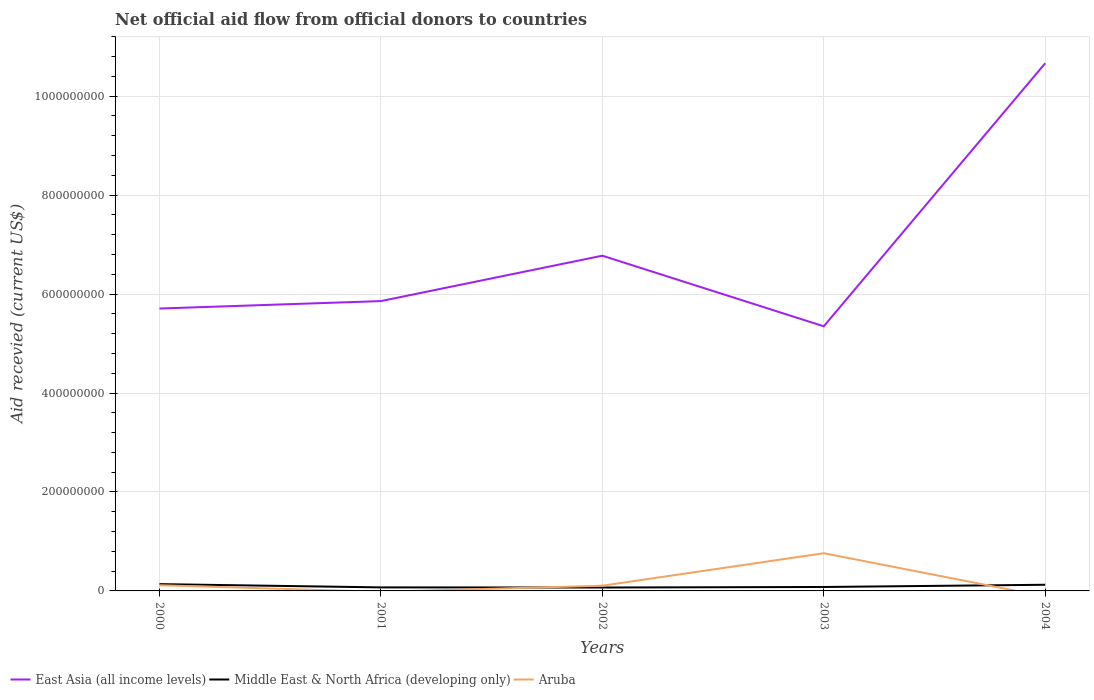How many different coloured lines are there?
Ensure brevity in your answer.  3. Does the line corresponding to East Asia (all income levels) intersect with the line corresponding to Aruba?
Make the answer very short. No. Is the number of lines equal to the number of legend labels?
Provide a succinct answer. No. Across all years, what is the maximum total aid received in Middle East & North Africa (developing only)?
Ensure brevity in your answer.  6.88e+06. What is the total total aid received in East Asia (all income levels) in the graph?
Offer a very short reply. 3.59e+07. What is the difference between the highest and the second highest total aid received in East Asia (all income levels)?
Your answer should be very brief. 5.32e+08. Does the graph contain grids?
Ensure brevity in your answer.  Yes. How many legend labels are there?
Offer a very short reply. 3. What is the title of the graph?
Your answer should be very brief. Net official aid flow from official donors to countries. Does "Burkina Faso" appear as one of the legend labels in the graph?
Your answer should be very brief. No. What is the label or title of the Y-axis?
Give a very brief answer. Aid recevied (current US$). What is the Aid recevied (current US$) of East Asia (all income levels) in 2000?
Your answer should be compact. 5.71e+08. What is the Aid recevied (current US$) of Middle East & North Africa (developing only) in 2000?
Provide a succinct answer. 1.38e+07. What is the Aid recevied (current US$) of Aruba in 2000?
Your response must be concise. 1.15e+07. What is the Aid recevied (current US$) in East Asia (all income levels) in 2001?
Make the answer very short. 5.86e+08. What is the Aid recevied (current US$) of Middle East & North Africa (developing only) in 2001?
Your response must be concise. 7.14e+06. What is the Aid recevied (current US$) of East Asia (all income levels) in 2002?
Ensure brevity in your answer.  6.78e+08. What is the Aid recevied (current US$) of Middle East & North Africa (developing only) in 2002?
Offer a very short reply. 6.88e+06. What is the Aid recevied (current US$) in Aruba in 2002?
Offer a terse response. 1.05e+07. What is the Aid recevied (current US$) of East Asia (all income levels) in 2003?
Give a very brief answer. 5.35e+08. What is the Aid recevied (current US$) in Middle East & North Africa (developing only) in 2003?
Ensure brevity in your answer.  7.95e+06. What is the Aid recevied (current US$) in Aruba in 2003?
Provide a succinct answer. 7.62e+07. What is the Aid recevied (current US$) in East Asia (all income levels) in 2004?
Provide a short and direct response. 1.07e+09. What is the Aid recevied (current US$) of Middle East & North Africa (developing only) in 2004?
Make the answer very short. 1.24e+07. What is the Aid recevied (current US$) of Aruba in 2004?
Provide a short and direct response. 0. Across all years, what is the maximum Aid recevied (current US$) of East Asia (all income levels)?
Provide a succinct answer. 1.07e+09. Across all years, what is the maximum Aid recevied (current US$) of Middle East & North Africa (developing only)?
Ensure brevity in your answer.  1.38e+07. Across all years, what is the maximum Aid recevied (current US$) of Aruba?
Ensure brevity in your answer.  7.62e+07. Across all years, what is the minimum Aid recevied (current US$) of East Asia (all income levels)?
Your response must be concise. 5.35e+08. Across all years, what is the minimum Aid recevied (current US$) of Middle East & North Africa (developing only)?
Offer a terse response. 6.88e+06. Across all years, what is the minimum Aid recevied (current US$) in Aruba?
Your answer should be compact. 0. What is the total Aid recevied (current US$) in East Asia (all income levels) in the graph?
Offer a terse response. 3.44e+09. What is the total Aid recevied (current US$) of Middle East & North Africa (developing only) in the graph?
Your answer should be compact. 4.82e+07. What is the total Aid recevied (current US$) in Aruba in the graph?
Offer a terse response. 9.82e+07. What is the difference between the Aid recevied (current US$) of East Asia (all income levels) in 2000 and that in 2001?
Give a very brief answer. -1.50e+07. What is the difference between the Aid recevied (current US$) of Middle East & North Africa (developing only) in 2000 and that in 2001?
Ensure brevity in your answer.  6.61e+06. What is the difference between the Aid recevied (current US$) of East Asia (all income levels) in 2000 and that in 2002?
Your answer should be compact. -1.07e+08. What is the difference between the Aid recevied (current US$) in Middle East & North Africa (developing only) in 2000 and that in 2002?
Make the answer very short. 6.87e+06. What is the difference between the Aid recevied (current US$) of Aruba in 2000 and that in 2002?
Provide a short and direct response. 1.01e+06. What is the difference between the Aid recevied (current US$) of East Asia (all income levels) in 2000 and that in 2003?
Offer a terse response. 3.59e+07. What is the difference between the Aid recevied (current US$) in Middle East & North Africa (developing only) in 2000 and that in 2003?
Make the answer very short. 5.80e+06. What is the difference between the Aid recevied (current US$) of Aruba in 2000 and that in 2003?
Provide a succinct answer. -6.47e+07. What is the difference between the Aid recevied (current US$) of East Asia (all income levels) in 2000 and that in 2004?
Your answer should be compact. -4.96e+08. What is the difference between the Aid recevied (current US$) of Middle East & North Africa (developing only) in 2000 and that in 2004?
Your answer should be compact. 1.32e+06. What is the difference between the Aid recevied (current US$) of East Asia (all income levels) in 2001 and that in 2002?
Make the answer very short. -9.18e+07. What is the difference between the Aid recevied (current US$) in Middle East & North Africa (developing only) in 2001 and that in 2002?
Provide a succinct answer. 2.60e+05. What is the difference between the Aid recevied (current US$) in East Asia (all income levels) in 2001 and that in 2003?
Your answer should be compact. 5.10e+07. What is the difference between the Aid recevied (current US$) of Middle East & North Africa (developing only) in 2001 and that in 2003?
Provide a succinct answer. -8.10e+05. What is the difference between the Aid recevied (current US$) of East Asia (all income levels) in 2001 and that in 2004?
Ensure brevity in your answer.  -4.81e+08. What is the difference between the Aid recevied (current US$) in Middle East & North Africa (developing only) in 2001 and that in 2004?
Keep it short and to the point. -5.29e+06. What is the difference between the Aid recevied (current US$) in East Asia (all income levels) in 2002 and that in 2003?
Give a very brief answer. 1.43e+08. What is the difference between the Aid recevied (current US$) in Middle East & North Africa (developing only) in 2002 and that in 2003?
Make the answer very short. -1.07e+06. What is the difference between the Aid recevied (current US$) in Aruba in 2002 and that in 2003?
Ensure brevity in your answer.  -6.57e+07. What is the difference between the Aid recevied (current US$) of East Asia (all income levels) in 2002 and that in 2004?
Give a very brief answer. -3.89e+08. What is the difference between the Aid recevied (current US$) of Middle East & North Africa (developing only) in 2002 and that in 2004?
Your answer should be compact. -5.55e+06. What is the difference between the Aid recevied (current US$) in East Asia (all income levels) in 2003 and that in 2004?
Your response must be concise. -5.32e+08. What is the difference between the Aid recevied (current US$) of Middle East & North Africa (developing only) in 2003 and that in 2004?
Make the answer very short. -4.48e+06. What is the difference between the Aid recevied (current US$) in East Asia (all income levels) in 2000 and the Aid recevied (current US$) in Middle East & North Africa (developing only) in 2001?
Give a very brief answer. 5.64e+08. What is the difference between the Aid recevied (current US$) of East Asia (all income levels) in 2000 and the Aid recevied (current US$) of Middle East & North Africa (developing only) in 2002?
Provide a short and direct response. 5.64e+08. What is the difference between the Aid recevied (current US$) of East Asia (all income levels) in 2000 and the Aid recevied (current US$) of Aruba in 2002?
Your response must be concise. 5.60e+08. What is the difference between the Aid recevied (current US$) in Middle East & North Africa (developing only) in 2000 and the Aid recevied (current US$) in Aruba in 2002?
Offer a terse response. 3.26e+06. What is the difference between the Aid recevied (current US$) in East Asia (all income levels) in 2000 and the Aid recevied (current US$) in Middle East & North Africa (developing only) in 2003?
Give a very brief answer. 5.63e+08. What is the difference between the Aid recevied (current US$) in East Asia (all income levels) in 2000 and the Aid recevied (current US$) in Aruba in 2003?
Your response must be concise. 4.95e+08. What is the difference between the Aid recevied (current US$) in Middle East & North Africa (developing only) in 2000 and the Aid recevied (current US$) in Aruba in 2003?
Your answer should be compact. -6.25e+07. What is the difference between the Aid recevied (current US$) of East Asia (all income levels) in 2000 and the Aid recevied (current US$) of Middle East & North Africa (developing only) in 2004?
Ensure brevity in your answer.  5.58e+08. What is the difference between the Aid recevied (current US$) of East Asia (all income levels) in 2001 and the Aid recevied (current US$) of Middle East & North Africa (developing only) in 2002?
Your answer should be compact. 5.79e+08. What is the difference between the Aid recevied (current US$) in East Asia (all income levels) in 2001 and the Aid recevied (current US$) in Aruba in 2002?
Provide a succinct answer. 5.75e+08. What is the difference between the Aid recevied (current US$) in Middle East & North Africa (developing only) in 2001 and the Aid recevied (current US$) in Aruba in 2002?
Give a very brief answer. -3.35e+06. What is the difference between the Aid recevied (current US$) of East Asia (all income levels) in 2001 and the Aid recevied (current US$) of Middle East & North Africa (developing only) in 2003?
Provide a short and direct response. 5.78e+08. What is the difference between the Aid recevied (current US$) of East Asia (all income levels) in 2001 and the Aid recevied (current US$) of Aruba in 2003?
Your response must be concise. 5.10e+08. What is the difference between the Aid recevied (current US$) in Middle East & North Africa (developing only) in 2001 and the Aid recevied (current US$) in Aruba in 2003?
Ensure brevity in your answer.  -6.91e+07. What is the difference between the Aid recevied (current US$) of East Asia (all income levels) in 2001 and the Aid recevied (current US$) of Middle East & North Africa (developing only) in 2004?
Your answer should be very brief. 5.73e+08. What is the difference between the Aid recevied (current US$) in East Asia (all income levels) in 2002 and the Aid recevied (current US$) in Middle East & North Africa (developing only) in 2003?
Offer a terse response. 6.70e+08. What is the difference between the Aid recevied (current US$) in East Asia (all income levels) in 2002 and the Aid recevied (current US$) in Aruba in 2003?
Keep it short and to the point. 6.01e+08. What is the difference between the Aid recevied (current US$) in Middle East & North Africa (developing only) in 2002 and the Aid recevied (current US$) in Aruba in 2003?
Provide a succinct answer. -6.93e+07. What is the difference between the Aid recevied (current US$) in East Asia (all income levels) in 2002 and the Aid recevied (current US$) in Middle East & North Africa (developing only) in 2004?
Give a very brief answer. 6.65e+08. What is the difference between the Aid recevied (current US$) of East Asia (all income levels) in 2003 and the Aid recevied (current US$) of Middle East & North Africa (developing only) in 2004?
Your response must be concise. 5.22e+08. What is the average Aid recevied (current US$) in East Asia (all income levels) per year?
Your answer should be compact. 6.87e+08. What is the average Aid recevied (current US$) in Middle East & North Africa (developing only) per year?
Provide a short and direct response. 9.63e+06. What is the average Aid recevied (current US$) of Aruba per year?
Provide a succinct answer. 1.96e+07. In the year 2000, what is the difference between the Aid recevied (current US$) of East Asia (all income levels) and Aid recevied (current US$) of Middle East & North Africa (developing only)?
Your response must be concise. 5.57e+08. In the year 2000, what is the difference between the Aid recevied (current US$) of East Asia (all income levels) and Aid recevied (current US$) of Aruba?
Offer a very short reply. 5.59e+08. In the year 2000, what is the difference between the Aid recevied (current US$) in Middle East & North Africa (developing only) and Aid recevied (current US$) in Aruba?
Your response must be concise. 2.25e+06. In the year 2001, what is the difference between the Aid recevied (current US$) in East Asia (all income levels) and Aid recevied (current US$) in Middle East & North Africa (developing only)?
Provide a short and direct response. 5.79e+08. In the year 2002, what is the difference between the Aid recevied (current US$) of East Asia (all income levels) and Aid recevied (current US$) of Middle East & North Africa (developing only)?
Offer a terse response. 6.71e+08. In the year 2002, what is the difference between the Aid recevied (current US$) in East Asia (all income levels) and Aid recevied (current US$) in Aruba?
Offer a very short reply. 6.67e+08. In the year 2002, what is the difference between the Aid recevied (current US$) in Middle East & North Africa (developing only) and Aid recevied (current US$) in Aruba?
Your answer should be very brief. -3.61e+06. In the year 2003, what is the difference between the Aid recevied (current US$) of East Asia (all income levels) and Aid recevied (current US$) of Middle East & North Africa (developing only)?
Provide a short and direct response. 5.27e+08. In the year 2003, what is the difference between the Aid recevied (current US$) in East Asia (all income levels) and Aid recevied (current US$) in Aruba?
Make the answer very short. 4.59e+08. In the year 2003, what is the difference between the Aid recevied (current US$) of Middle East & North Africa (developing only) and Aid recevied (current US$) of Aruba?
Offer a very short reply. -6.83e+07. In the year 2004, what is the difference between the Aid recevied (current US$) of East Asia (all income levels) and Aid recevied (current US$) of Middle East & North Africa (developing only)?
Provide a short and direct response. 1.05e+09. What is the ratio of the Aid recevied (current US$) in East Asia (all income levels) in 2000 to that in 2001?
Provide a short and direct response. 0.97. What is the ratio of the Aid recevied (current US$) of Middle East & North Africa (developing only) in 2000 to that in 2001?
Make the answer very short. 1.93. What is the ratio of the Aid recevied (current US$) in East Asia (all income levels) in 2000 to that in 2002?
Keep it short and to the point. 0.84. What is the ratio of the Aid recevied (current US$) in Middle East & North Africa (developing only) in 2000 to that in 2002?
Offer a terse response. 2. What is the ratio of the Aid recevied (current US$) in Aruba in 2000 to that in 2002?
Provide a succinct answer. 1.1. What is the ratio of the Aid recevied (current US$) of East Asia (all income levels) in 2000 to that in 2003?
Provide a short and direct response. 1.07. What is the ratio of the Aid recevied (current US$) in Middle East & North Africa (developing only) in 2000 to that in 2003?
Ensure brevity in your answer.  1.73. What is the ratio of the Aid recevied (current US$) in Aruba in 2000 to that in 2003?
Keep it short and to the point. 0.15. What is the ratio of the Aid recevied (current US$) in East Asia (all income levels) in 2000 to that in 2004?
Provide a short and direct response. 0.54. What is the ratio of the Aid recevied (current US$) of Middle East & North Africa (developing only) in 2000 to that in 2004?
Your response must be concise. 1.11. What is the ratio of the Aid recevied (current US$) of East Asia (all income levels) in 2001 to that in 2002?
Give a very brief answer. 0.86. What is the ratio of the Aid recevied (current US$) in Middle East & North Africa (developing only) in 2001 to that in 2002?
Offer a very short reply. 1.04. What is the ratio of the Aid recevied (current US$) of East Asia (all income levels) in 2001 to that in 2003?
Offer a terse response. 1.1. What is the ratio of the Aid recevied (current US$) in Middle East & North Africa (developing only) in 2001 to that in 2003?
Ensure brevity in your answer.  0.9. What is the ratio of the Aid recevied (current US$) of East Asia (all income levels) in 2001 to that in 2004?
Offer a very short reply. 0.55. What is the ratio of the Aid recevied (current US$) of Middle East & North Africa (developing only) in 2001 to that in 2004?
Make the answer very short. 0.57. What is the ratio of the Aid recevied (current US$) in East Asia (all income levels) in 2002 to that in 2003?
Your response must be concise. 1.27. What is the ratio of the Aid recevied (current US$) of Middle East & North Africa (developing only) in 2002 to that in 2003?
Offer a terse response. 0.87. What is the ratio of the Aid recevied (current US$) of Aruba in 2002 to that in 2003?
Ensure brevity in your answer.  0.14. What is the ratio of the Aid recevied (current US$) of East Asia (all income levels) in 2002 to that in 2004?
Offer a very short reply. 0.64. What is the ratio of the Aid recevied (current US$) of Middle East & North Africa (developing only) in 2002 to that in 2004?
Your answer should be compact. 0.55. What is the ratio of the Aid recevied (current US$) in East Asia (all income levels) in 2003 to that in 2004?
Your answer should be compact. 0.5. What is the ratio of the Aid recevied (current US$) in Middle East & North Africa (developing only) in 2003 to that in 2004?
Your response must be concise. 0.64. What is the difference between the highest and the second highest Aid recevied (current US$) of East Asia (all income levels)?
Your response must be concise. 3.89e+08. What is the difference between the highest and the second highest Aid recevied (current US$) in Middle East & North Africa (developing only)?
Keep it short and to the point. 1.32e+06. What is the difference between the highest and the second highest Aid recevied (current US$) in Aruba?
Keep it short and to the point. 6.47e+07. What is the difference between the highest and the lowest Aid recevied (current US$) in East Asia (all income levels)?
Ensure brevity in your answer.  5.32e+08. What is the difference between the highest and the lowest Aid recevied (current US$) of Middle East & North Africa (developing only)?
Offer a terse response. 6.87e+06. What is the difference between the highest and the lowest Aid recevied (current US$) in Aruba?
Provide a short and direct response. 7.62e+07. 